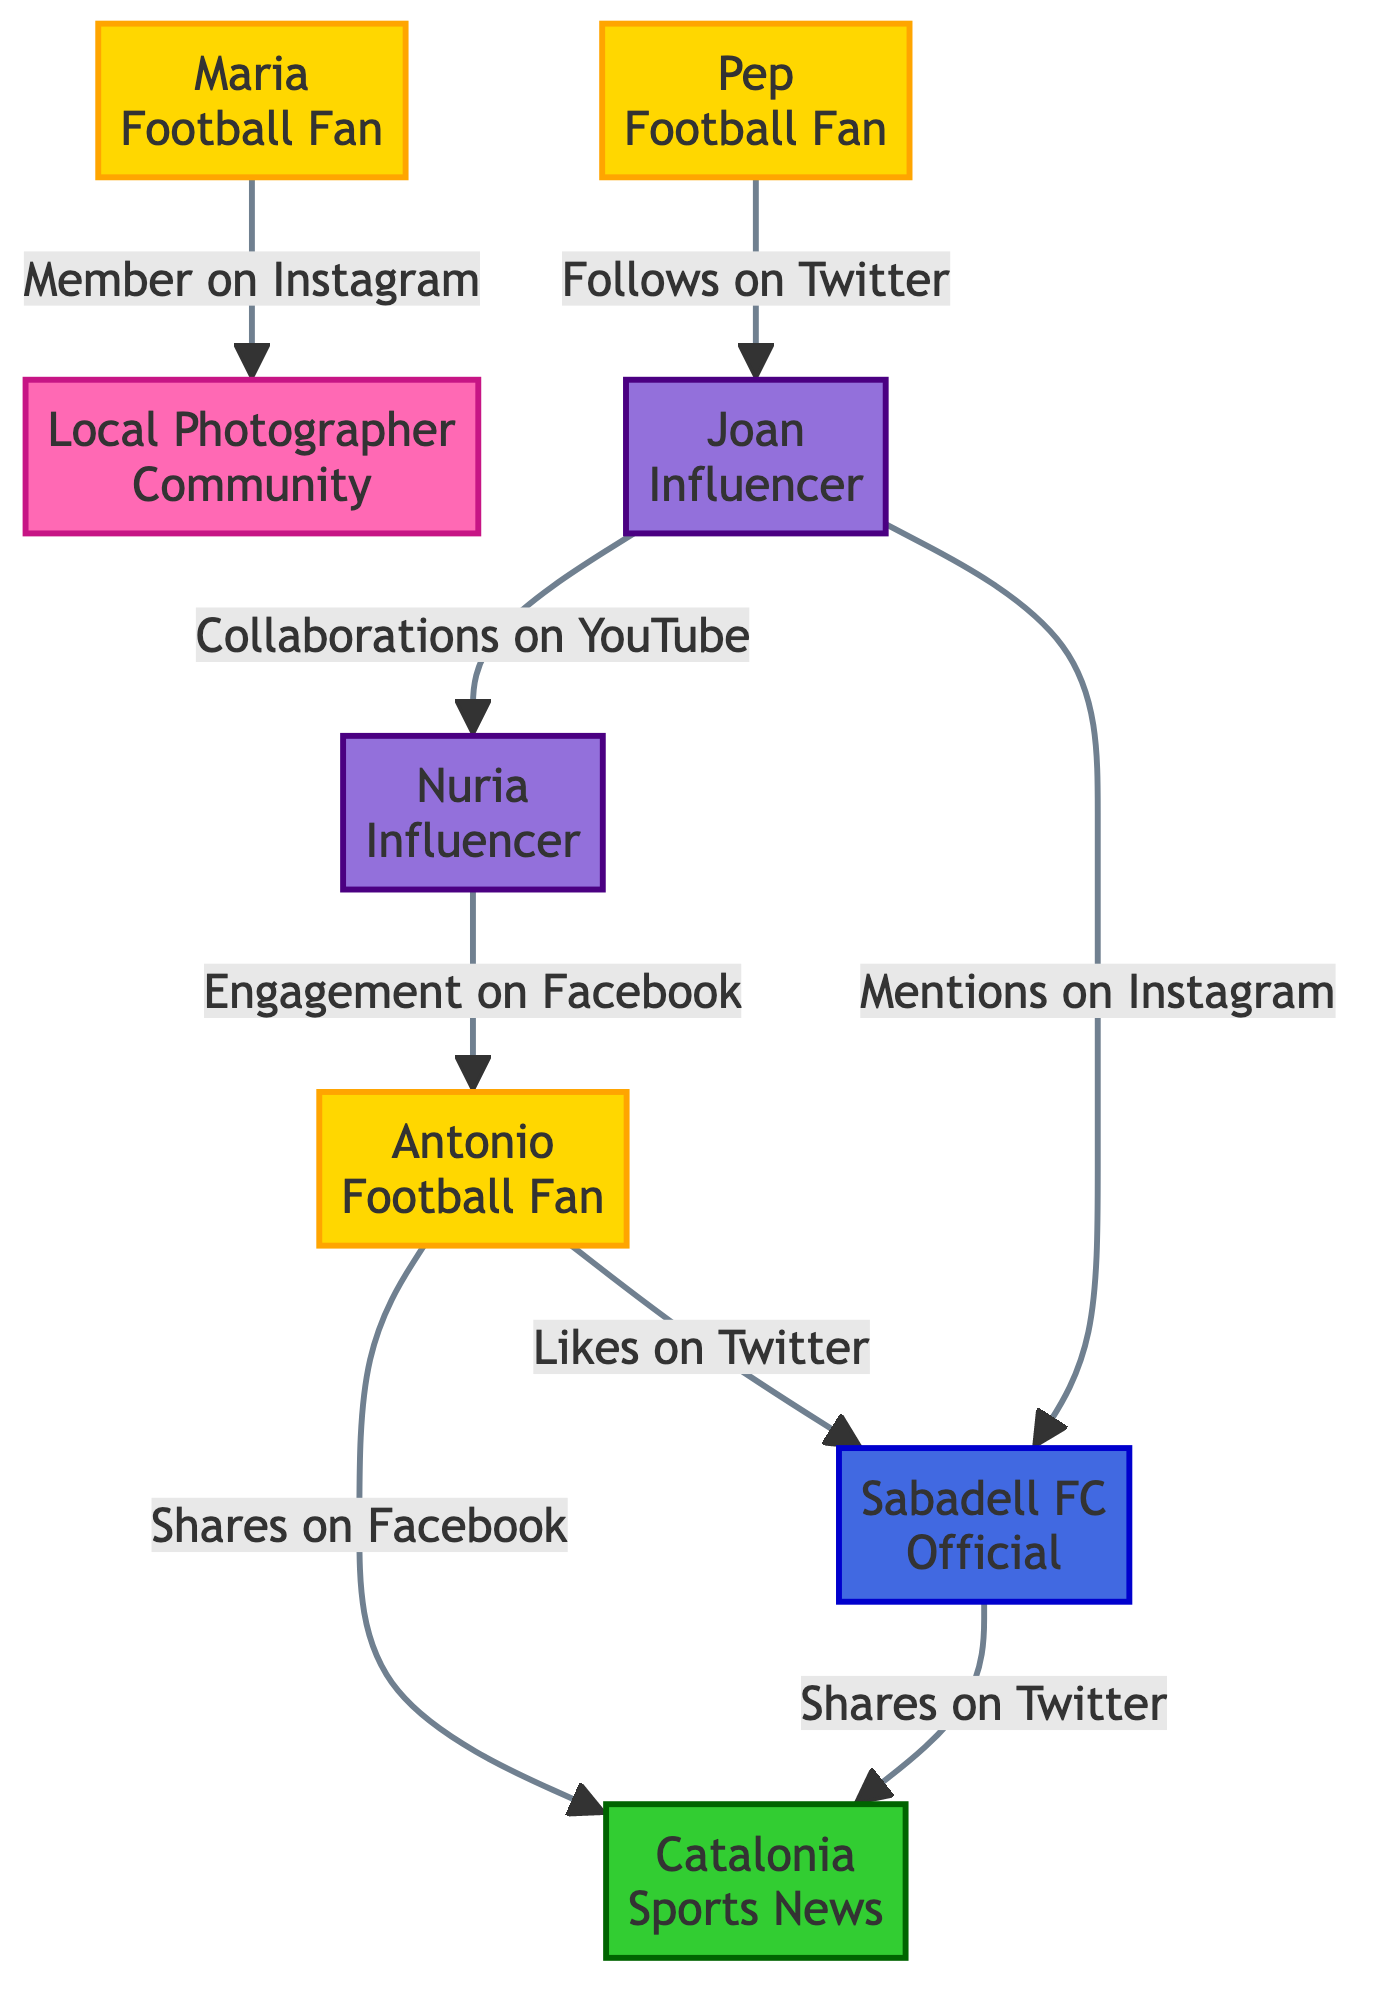What is the total number of nodes in the diagram? The diagram lists 8 different entities: 5 football fans, 2 influencers, 1 football club, and 1 media outlet. Thus, the total count of nodes is 8.
Answer: 8 Which fan has the most connections? By examining the edges, we can see that 'Antonio' has 2 connections: one to 'Sabadell FC Official' and one to 'Catalonia Sports News'. Other fans have fewer connections, making 'Antonio' the fan with the most connections.
Answer: Antonio What type of interaction does 'Joan' have with 'Sabadell FC Official'? 'Joan' interacts with 'Sabadell FC Official' by mentioning them on Instagram, according to the directed edge in the diagram that connects them.
Answer: Mentions How many social media platforms are represented in the diagram? The social media platforms represented are Twitter, Facebook, and Instagram. Counting these gives us a total of 3 distinct platforms present in the diagram.
Answer: 3 Who engages with 'Antonio' on Facebook? The diagram shows that 'Nuria', the influencer, has an engagement interaction with 'Antonio' on Facebook, which is indicated by the directed edge connecting them.
Answer: Nuria What is the total number of interactions represented in the diagram? There are 8 edges in the diagram, each representing a unique interaction between different nodes. Thus, the total number of interactions is 8.
Answer: 8 Which football fan is a member of the Local Photographer Community? According to the interactions, 'Maria' is the football fan who is listed as a member of the Local Photographer Community on Instagram.
Answer: Maria Which influencer has more followers? Comparing the follower counts, 'Nuria' has 20,000 followers while 'Joan' has 15,000 followers, indicating that 'Nuria' has more followers than 'Joan'.
Answer: Nuria 